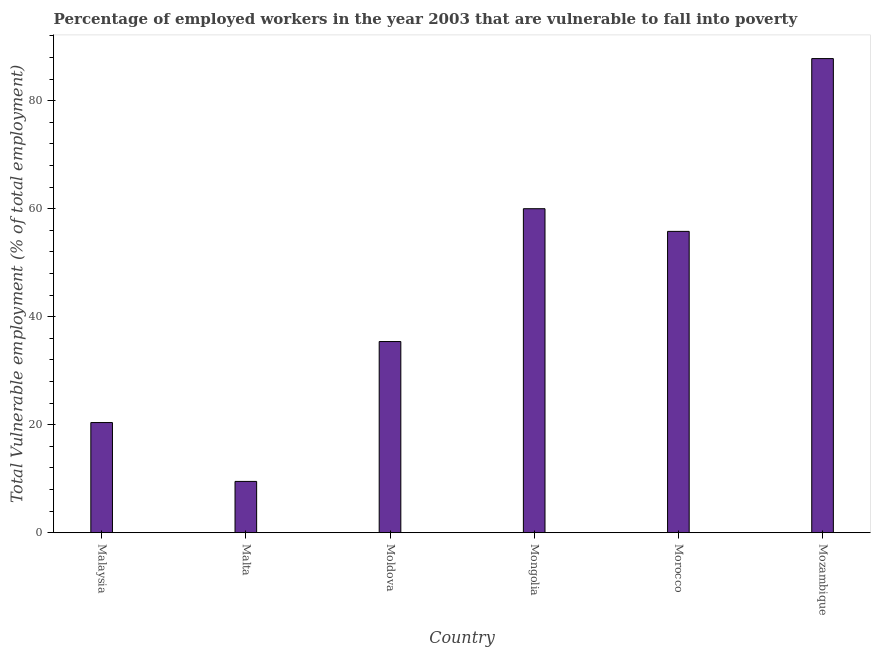What is the title of the graph?
Offer a very short reply. Percentage of employed workers in the year 2003 that are vulnerable to fall into poverty. What is the label or title of the Y-axis?
Provide a short and direct response. Total Vulnerable employment (% of total employment). What is the total vulnerable employment in Mozambique?
Your response must be concise. 87.8. Across all countries, what is the maximum total vulnerable employment?
Ensure brevity in your answer.  87.8. In which country was the total vulnerable employment maximum?
Make the answer very short. Mozambique. In which country was the total vulnerable employment minimum?
Your response must be concise. Malta. What is the sum of the total vulnerable employment?
Keep it short and to the point. 268.9. What is the difference between the total vulnerable employment in Moldova and Morocco?
Offer a terse response. -20.4. What is the average total vulnerable employment per country?
Offer a very short reply. 44.82. What is the median total vulnerable employment?
Make the answer very short. 45.6. In how many countries, is the total vulnerable employment greater than 44 %?
Offer a terse response. 3. What is the ratio of the total vulnerable employment in Malaysia to that in Mozambique?
Keep it short and to the point. 0.23. What is the difference between the highest and the second highest total vulnerable employment?
Provide a succinct answer. 27.8. Is the sum of the total vulnerable employment in Malta and Mozambique greater than the maximum total vulnerable employment across all countries?
Keep it short and to the point. Yes. What is the difference between the highest and the lowest total vulnerable employment?
Ensure brevity in your answer.  78.3. In how many countries, is the total vulnerable employment greater than the average total vulnerable employment taken over all countries?
Ensure brevity in your answer.  3. Are all the bars in the graph horizontal?
Your answer should be very brief. No. What is the difference between two consecutive major ticks on the Y-axis?
Offer a terse response. 20. Are the values on the major ticks of Y-axis written in scientific E-notation?
Offer a very short reply. No. What is the Total Vulnerable employment (% of total employment) in Malaysia?
Make the answer very short. 20.4. What is the Total Vulnerable employment (% of total employment) of Malta?
Your response must be concise. 9.5. What is the Total Vulnerable employment (% of total employment) in Moldova?
Your answer should be very brief. 35.4. What is the Total Vulnerable employment (% of total employment) of Morocco?
Offer a terse response. 55.8. What is the Total Vulnerable employment (% of total employment) of Mozambique?
Your answer should be compact. 87.8. What is the difference between the Total Vulnerable employment (% of total employment) in Malaysia and Malta?
Offer a very short reply. 10.9. What is the difference between the Total Vulnerable employment (% of total employment) in Malaysia and Moldova?
Provide a short and direct response. -15. What is the difference between the Total Vulnerable employment (% of total employment) in Malaysia and Mongolia?
Offer a terse response. -39.6. What is the difference between the Total Vulnerable employment (% of total employment) in Malaysia and Morocco?
Provide a succinct answer. -35.4. What is the difference between the Total Vulnerable employment (% of total employment) in Malaysia and Mozambique?
Provide a succinct answer. -67.4. What is the difference between the Total Vulnerable employment (% of total employment) in Malta and Moldova?
Your response must be concise. -25.9. What is the difference between the Total Vulnerable employment (% of total employment) in Malta and Mongolia?
Provide a short and direct response. -50.5. What is the difference between the Total Vulnerable employment (% of total employment) in Malta and Morocco?
Make the answer very short. -46.3. What is the difference between the Total Vulnerable employment (% of total employment) in Malta and Mozambique?
Your answer should be compact. -78.3. What is the difference between the Total Vulnerable employment (% of total employment) in Moldova and Mongolia?
Your response must be concise. -24.6. What is the difference between the Total Vulnerable employment (% of total employment) in Moldova and Morocco?
Offer a terse response. -20.4. What is the difference between the Total Vulnerable employment (% of total employment) in Moldova and Mozambique?
Give a very brief answer. -52.4. What is the difference between the Total Vulnerable employment (% of total employment) in Mongolia and Mozambique?
Your answer should be very brief. -27.8. What is the difference between the Total Vulnerable employment (% of total employment) in Morocco and Mozambique?
Provide a succinct answer. -32. What is the ratio of the Total Vulnerable employment (% of total employment) in Malaysia to that in Malta?
Provide a succinct answer. 2.15. What is the ratio of the Total Vulnerable employment (% of total employment) in Malaysia to that in Moldova?
Provide a succinct answer. 0.58. What is the ratio of the Total Vulnerable employment (% of total employment) in Malaysia to that in Mongolia?
Offer a terse response. 0.34. What is the ratio of the Total Vulnerable employment (% of total employment) in Malaysia to that in Morocco?
Ensure brevity in your answer.  0.37. What is the ratio of the Total Vulnerable employment (% of total employment) in Malaysia to that in Mozambique?
Give a very brief answer. 0.23. What is the ratio of the Total Vulnerable employment (% of total employment) in Malta to that in Moldova?
Ensure brevity in your answer.  0.27. What is the ratio of the Total Vulnerable employment (% of total employment) in Malta to that in Mongolia?
Your response must be concise. 0.16. What is the ratio of the Total Vulnerable employment (% of total employment) in Malta to that in Morocco?
Your answer should be very brief. 0.17. What is the ratio of the Total Vulnerable employment (% of total employment) in Malta to that in Mozambique?
Make the answer very short. 0.11. What is the ratio of the Total Vulnerable employment (% of total employment) in Moldova to that in Mongolia?
Give a very brief answer. 0.59. What is the ratio of the Total Vulnerable employment (% of total employment) in Moldova to that in Morocco?
Make the answer very short. 0.63. What is the ratio of the Total Vulnerable employment (% of total employment) in Moldova to that in Mozambique?
Provide a short and direct response. 0.4. What is the ratio of the Total Vulnerable employment (% of total employment) in Mongolia to that in Morocco?
Your answer should be compact. 1.07. What is the ratio of the Total Vulnerable employment (% of total employment) in Mongolia to that in Mozambique?
Your response must be concise. 0.68. What is the ratio of the Total Vulnerable employment (% of total employment) in Morocco to that in Mozambique?
Your answer should be very brief. 0.64. 